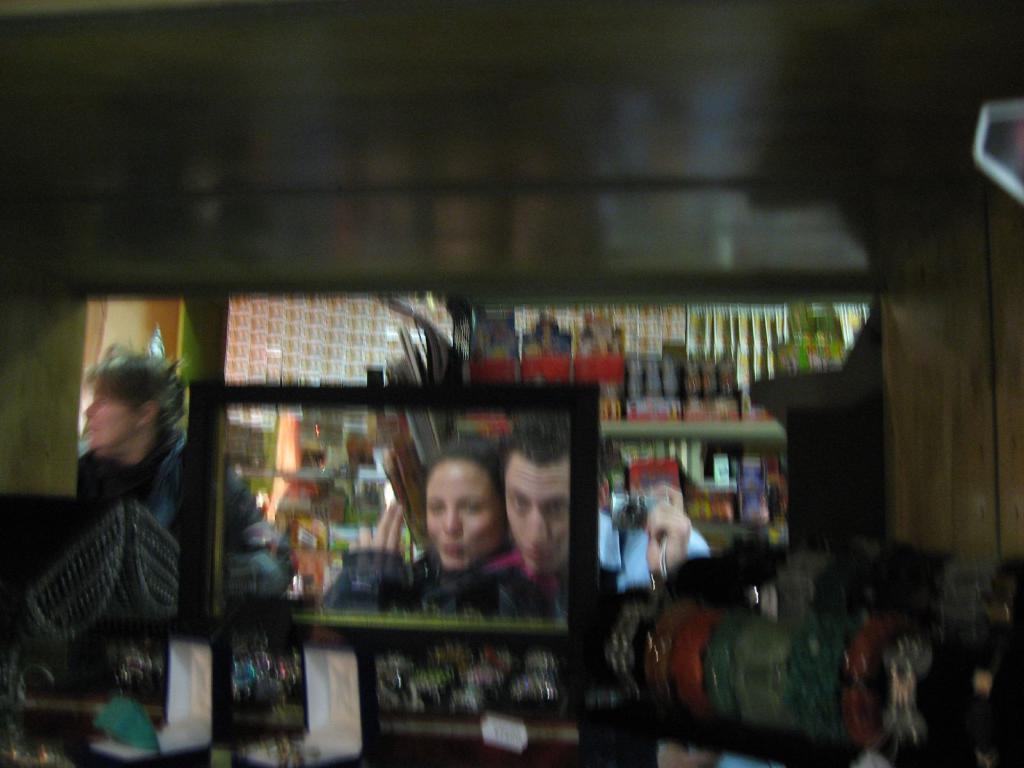Describe this image in one or two sentences. It is blur image,in front of the store there is a mirror and in the mirror there is a man and a woman are taking a photo. 